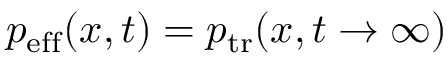Convert formula to latex. <formula><loc_0><loc_0><loc_500><loc_500>p _ { e f f } ( x , t ) = p _ { t r } ( x , t \rightarrow \infty )</formula> 